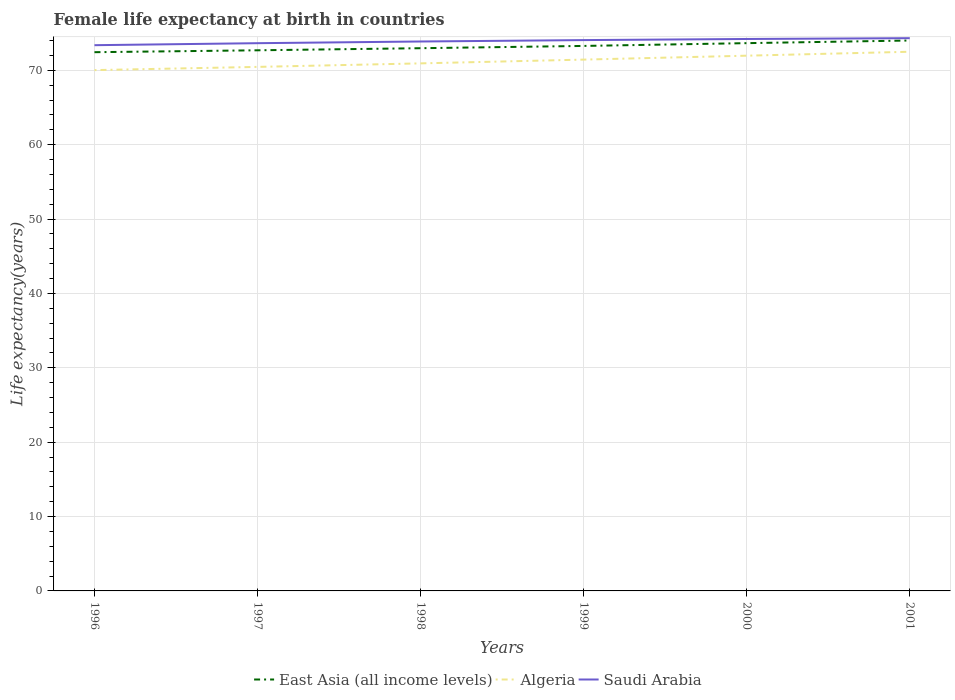How many different coloured lines are there?
Ensure brevity in your answer.  3. Does the line corresponding to Saudi Arabia intersect with the line corresponding to Algeria?
Make the answer very short. No. Across all years, what is the maximum female life expectancy at birth in East Asia (all income levels)?
Offer a very short reply. 72.44. What is the total female life expectancy at birth in Saudi Arabia in the graph?
Your answer should be very brief. -0.11. What is the difference between the highest and the second highest female life expectancy at birth in Saudi Arabia?
Ensure brevity in your answer.  0.94. Is the female life expectancy at birth in East Asia (all income levels) strictly greater than the female life expectancy at birth in Algeria over the years?
Give a very brief answer. No. How many lines are there?
Provide a short and direct response. 3. What is the difference between two consecutive major ticks on the Y-axis?
Make the answer very short. 10. Does the graph contain grids?
Your response must be concise. Yes. Where does the legend appear in the graph?
Ensure brevity in your answer.  Bottom center. How many legend labels are there?
Keep it short and to the point. 3. What is the title of the graph?
Your answer should be very brief. Female life expectancy at birth in countries. Does "Tonga" appear as one of the legend labels in the graph?
Give a very brief answer. No. What is the label or title of the X-axis?
Your answer should be compact. Years. What is the label or title of the Y-axis?
Give a very brief answer. Life expectancy(years). What is the Life expectancy(years) in East Asia (all income levels) in 1996?
Your response must be concise. 72.44. What is the Life expectancy(years) of Algeria in 1996?
Offer a terse response. 70.03. What is the Life expectancy(years) in Saudi Arabia in 1996?
Provide a short and direct response. 73.38. What is the Life expectancy(years) in East Asia (all income levels) in 1997?
Provide a succinct answer. 72.7. What is the Life expectancy(years) in Algeria in 1997?
Your answer should be compact. 70.47. What is the Life expectancy(years) in Saudi Arabia in 1997?
Keep it short and to the point. 73.65. What is the Life expectancy(years) of East Asia (all income levels) in 1998?
Your answer should be compact. 72.98. What is the Life expectancy(years) of Algeria in 1998?
Give a very brief answer. 70.94. What is the Life expectancy(years) in Saudi Arabia in 1998?
Your response must be concise. 73.88. What is the Life expectancy(years) in East Asia (all income levels) in 1999?
Give a very brief answer. 73.28. What is the Life expectancy(years) in Algeria in 1999?
Provide a short and direct response. 71.45. What is the Life expectancy(years) of Saudi Arabia in 1999?
Your answer should be very brief. 74.07. What is the Life expectancy(years) of East Asia (all income levels) in 2000?
Keep it short and to the point. 73.66. What is the Life expectancy(years) in Algeria in 2000?
Provide a short and direct response. 71.97. What is the Life expectancy(years) in Saudi Arabia in 2000?
Offer a very short reply. 74.22. What is the Life expectancy(years) of East Asia (all income levels) in 2001?
Your answer should be compact. 74.01. What is the Life expectancy(years) of Algeria in 2001?
Your response must be concise. 72.5. What is the Life expectancy(years) in Saudi Arabia in 2001?
Keep it short and to the point. 74.33. Across all years, what is the maximum Life expectancy(years) in East Asia (all income levels)?
Give a very brief answer. 74.01. Across all years, what is the maximum Life expectancy(years) in Algeria?
Offer a very short reply. 72.5. Across all years, what is the maximum Life expectancy(years) of Saudi Arabia?
Make the answer very short. 74.33. Across all years, what is the minimum Life expectancy(years) in East Asia (all income levels)?
Offer a terse response. 72.44. Across all years, what is the minimum Life expectancy(years) in Algeria?
Make the answer very short. 70.03. Across all years, what is the minimum Life expectancy(years) in Saudi Arabia?
Your answer should be compact. 73.38. What is the total Life expectancy(years) of East Asia (all income levels) in the graph?
Offer a very short reply. 439.08. What is the total Life expectancy(years) in Algeria in the graph?
Your response must be concise. 427.36. What is the total Life expectancy(years) in Saudi Arabia in the graph?
Your response must be concise. 443.53. What is the difference between the Life expectancy(years) in East Asia (all income levels) in 1996 and that in 1997?
Ensure brevity in your answer.  -0.26. What is the difference between the Life expectancy(years) in Algeria in 1996 and that in 1997?
Ensure brevity in your answer.  -0.43. What is the difference between the Life expectancy(years) of Saudi Arabia in 1996 and that in 1997?
Your answer should be very brief. -0.27. What is the difference between the Life expectancy(years) in East Asia (all income levels) in 1996 and that in 1998?
Keep it short and to the point. -0.54. What is the difference between the Life expectancy(years) of Algeria in 1996 and that in 1998?
Provide a short and direct response. -0.91. What is the difference between the Life expectancy(years) of Saudi Arabia in 1996 and that in 1998?
Your answer should be very brief. -0.5. What is the difference between the Life expectancy(years) of East Asia (all income levels) in 1996 and that in 1999?
Keep it short and to the point. -0.84. What is the difference between the Life expectancy(years) of Algeria in 1996 and that in 1999?
Ensure brevity in your answer.  -1.41. What is the difference between the Life expectancy(years) in Saudi Arabia in 1996 and that in 1999?
Give a very brief answer. -0.69. What is the difference between the Life expectancy(years) of East Asia (all income levels) in 1996 and that in 2000?
Give a very brief answer. -1.22. What is the difference between the Life expectancy(years) in Algeria in 1996 and that in 2000?
Ensure brevity in your answer.  -1.94. What is the difference between the Life expectancy(years) in Saudi Arabia in 1996 and that in 2000?
Make the answer very short. -0.83. What is the difference between the Life expectancy(years) of East Asia (all income levels) in 1996 and that in 2001?
Your answer should be compact. -1.57. What is the difference between the Life expectancy(years) in Algeria in 1996 and that in 2001?
Offer a terse response. -2.47. What is the difference between the Life expectancy(years) of Saudi Arabia in 1996 and that in 2001?
Give a very brief answer. -0.94. What is the difference between the Life expectancy(years) in East Asia (all income levels) in 1997 and that in 1998?
Provide a succinct answer. -0.28. What is the difference between the Life expectancy(years) in Algeria in 1997 and that in 1998?
Ensure brevity in your answer.  -0.47. What is the difference between the Life expectancy(years) in Saudi Arabia in 1997 and that in 1998?
Offer a very short reply. -0.23. What is the difference between the Life expectancy(years) in East Asia (all income levels) in 1997 and that in 1999?
Keep it short and to the point. -0.59. What is the difference between the Life expectancy(years) of Algeria in 1997 and that in 1999?
Keep it short and to the point. -0.98. What is the difference between the Life expectancy(years) in Saudi Arabia in 1997 and that in 1999?
Your answer should be very brief. -0.42. What is the difference between the Life expectancy(years) of East Asia (all income levels) in 1997 and that in 2000?
Keep it short and to the point. -0.96. What is the difference between the Life expectancy(years) in Algeria in 1997 and that in 2000?
Offer a terse response. -1.51. What is the difference between the Life expectancy(years) of Saudi Arabia in 1997 and that in 2000?
Your answer should be compact. -0.56. What is the difference between the Life expectancy(years) of East Asia (all income levels) in 1997 and that in 2001?
Provide a succinct answer. -1.32. What is the difference between the Life expectancy(years) of Algeria in 1997 and that in 2001?
Provide a short and direct response. -2.04. What is the difference between the Life expectancy(years) of Saudi Arabia in 1997 and that in 2001?
Offer a terse response. -0.68. What is the difference between the Life expectancy(years) in East Asia (all income levels) in 1998 and that in 1999?
Ensure brevity in your answer.  -0.3. What is the difference between the Life expectancy(years) of Algeria in 1998 and that in 1999?
Your response must be concise. -0.51. What is the difference between the Life expectancy(years) in Saudi Arabia in 1998 and that in 1999?
Give a very brief answer. -0.19. What is the difference between the Life expectancy(years) of East Asia (all income levels) in 1998 and that in 2000?
Give a very brief answer. -0.68. What is the difference between the Life expectancy(years) of Algeria in 1998 and that in 2000?
Give a very brief answer. -1.03. What is the difference between the Life expectancy(years) in Saudi Arabia in 1998 and that in 2000?
Offer a very short reply. -0.34. What is the difference between the Life expectancy(years) of East Asia (all income levels) in 1998 and that in 2001?
Your answer should be very brief. -1.03. What is the difference between the Life expectancy(years) of Algeria in 1998 and that in 2001?
Keep it short and to the point. -1.56. What is the difference between the Life expectancy(years) of Saudi Arabia in 1998 and that in 2001?
Your answer should be very brief. -0.45. What is the difference between the Life expectancy(years) in East Asia (all income levels) in 1999 and that in 2000?
Provide a succinct answer. -0.37. What is the difference between the Life expectancy(years) of Algeria in 1999 and that in 2000?
Your answer should be very brief. -0.53. What is the difference between the Life expectancy(years) in Saudi Arabia in 1999 and that in 2000?
Keep it short and to the point. -0.15. What is the difference between the Life expectancy(years) in East Asia (all income levels) in 1999 and that in 2001?
Your answer should be compact. -0.73. What is the difference between the Life expectancy(years) of Algeria in 1999 and that in 2001?
Your answer should be compact. -1.06. What is the difference between the Life expectancy(years) in Saudi Arabia in 1999 and that in 2001?
Give a very brief answer. -0.26. What is the difference between the Life expectancy(years) of East Asia (all income levels) in 2000 and that in 2001?
Your answer should be very brief. -0.36. What is the difference between the Life expectancy(years) in Algeria in 2000 and that in 2001?
Make the answer very short. -0.53. What is the difference between the Life expectancy(years) of Saudi Arabia in 2000 and that in 2001?
Your answer should be compact. -0.11. What is the difference between the Life expectancy(years) of East Asia (all income levels) in 1996 and the Life expectancy(years) of Algeria in 1997?
Your answer should be very brief. 1.98. What is the difference between the Life expectancy(years) in East Asia (all income levels) in 1996 and the Life expectancy(years) in Saudi Arabia in 1997?
Give a very brief answer. -1.21. What is the difference between the Life expectancy(years) of Algeria in 1996 and the Life expectancy(years) of Saudi Arabia in 1997?
Your response must be concise. -3.62. What is the difference between the Life expectancy(years) of East Asia (all income levels) in 1996 and the Life expectancy(years) of Algeria in 1998?
Give a very brief answer. 1.5. What is the difference between the Life expectancy(years) in East Asia (all income levels) in 1996 and the Life expectancy(years) in Saudi Arabia in 1998?
Your response must be concise. -1.44. What is the difference between the Life expectancy(years) in Algeria in 1996 and the Life expectancy(years) in Saudi Arabia in 1998?
Give a very brief answer. -3.85. What is the difference between the Life expectancy(years) in East Asia (all income levels) in 1996 and the Life expectancy(years) in Saudi Arabia in 1999?
Offer a terse response. -1.63. What is the difference between the Life expectancy(years) of Algeria in 1996 and the Life expectancy(years) of Saudi Arabia in 1999?
Your answer should be very brief. -4.04. What is the difference between the Life expectancy(years) in East Asia (all income levels) in 1996 and the Life expectancy(years) in Algeria in 2000?
Your answer should be very brief. 0.47. What is the difference between the Life expectancy(years) of East Asia (all income levels) in 1996 and the Life expectancy(years) of Saudi Arabia in 2000?
Your answer should be compact. -1.78. What is the difference between the Life expectancy(years) in Algeria in 1996 and the Life expectancy(years) in Saudi Arabia in 2000?
Give a very brief answer. -4.18. What is the difference between the Life expectancy(years) in East Asia (all income levels) in 1996 and the Life expectancy(years) in Algeria in 2001?
Make the answer very short. -0.06. What is the difference between the Life expectancy(years) of East Asia (all income levels) in 1996 and the Life expectancy(years) of Saudi Arabia in 2001?
Your answer should be very brief. -1.89. What is the difference between the Life expectancy(years) of Algeria in 1996 and the Life expectancy(years) of Saudi Arabia in 2001?
Make the answer very short. -4.29. What is the difference between the Life expectancy(years) in East Asia (all income levels) in 1997 and the Life expectancy(years) in Algeria in 1998?
Provide a short and direct response. 1.76. What is the difference between the Life expectancy(years) in East Asia (all income levels) in 1997 and the Life expectancy(years) in Saudi Arabia in 1998?
Your answer should be very brief. -1.18. What is the difference between the Life expectancy(years) of Algeria in 1997 and the Life expectancy(years) of Saudi Arabia in 1998?
Keep it short and to the point. -3.42. What is the difference between the Life expectancy(years) of East Asia (all income levels) in 1997 and the Life expectancy(years) of Algeria in 1999?
Your answer should be compact. 1.25. What is the difference between the Life expectancy(years) in East Asia (all income levels) in 1997 and the Life expectancy(years) in Saudi Arabia in 1999?
Your answer should be very brief. -1.37. What is the difference between the Life expectancy(years) in Algeria in 1997 and the Life expectancy(years) in Saudi Arabia in 1999?
Offer a very short reply. -3.6. What is the difference between the Life expectancy(years) of East Asia (all income levels) in 1997 and the Life expectancy(years) of Algeria in 2000?
Ensure brevity in your answer.  0.73. What is the difference between the Life expectancy(years) of East Asia (all income levels) in 1997 and the Life expectancy(years) of Saudi Arabia in 2000?
Offer a very short reply. -1.52. What is the difference between the Life expectancy(years) in Algeria in 1997 and the Life expectancy(years) in Saudi Arabia in 2000?
Your answer should be compact. -3.75. What is the difference between the Life expectancy(years) in East Asia (all income levels) in 1997 and the Life expectancy(years) in Algeria in 2001?
Your answer should be very brief. 0.2. What is the difference between the Life expectancy(years) of East Asia (all income levels) in 1997 and the Life expectancy(years) of Saudi Arabia in 2001?
Provide a short and direct response. -1.63. What is the difference between the Life expectancy(years) of Algeria in 1997 and the Life expectancy(years) of Saudi Arabia in 2001?
Give a very brief answer. -3.86. What is the difference between the Life expectancy(years) of East Asia (all income levels) in 1998 and the Life expectancy(years) of Algeria in 1999?
Make the answer very short. 1.53. What is the difference between the Life expectancy(years) of East Asia (all income levels) in 1998 and the Life expectancy(years) of Saudi Arabia in 1999?
Offer a terse response. -1.09. What is the difference between the Life expectancy(years) in Algeria in 1998 and the Life expectancy(years) in Saudi Arabia in 1999?
Offer a terse response. -3.13. What is the difference between the Life expectancy(years) in East Asia (all income levels) in 1998 and the Life expectancy(years) in Saudi Arabia in 2000?
Your answer should be very brief. -1.24. What is the difference between the Life expectancy(years) in Algeria in 1998 and the Life expectancy(years) in Saudi Arabia in 2000?
Your response must be concise. -3.28. What is the difference between the Life expectancy(years) in East Asia (all income levels) in 1998 and the Life expectancy(years) in Algeria in 2001?
Make the answer very short. 0.48. What is the difference between the Life expectancy(years) in East Asia (all income levels) in 1998 and the Life expectancy(years) in Saudi Arabia in 2001?
Your answer should be compact. -1.35. What is the difference between the Life expectancy(years) of Algeria in 1998 and the Life expectancy(years) of Saudi Arabia in 2001?
Your answer should be very brief. -3.39. What is the difference between the Life expectancy(years) in East Asia (all income levels) in 1999 and the Life expectancy(years) in Algeria in 2000?
Ensure brevity in your answer.  1.31. What is the difference between the Life expectancy(years) of East Asia (all income levels) in 1999 and the Life expectancy(years) of Saudi Arabia in 2000?
Provide a succinct answer. -0.93. What is the difference between the Life expectancy(years) in Algeria in 1999 and the Life expectancy(years) in Saudi Arabia in 2000?
Provide a succinct answer. -2.77. What is the difference between the Life expectancy(years) of East Asia (all income levels) in 1999 and the Life expectancy(years) of Algeria in 2001?
Offer a terse response. 0.78. What is the difference between the Life expectancy(years) in East Asia (all income levels) in 1999 and the Life expectancy(years) in Saudi Arabia in 2001?
Your answer should be compact. -1.04. What is the difference between the Life expectancy(years) of Algeria in 1999 and the Life expectancy(years) of Saudi Arabia in 2001?
Ensure brevity in your answer.  -2.88. What is the difference between the Life expectancy(years) of East Asia (all income levels) in 2000 and the Life expectancy(years) of Algeria in 2001?
Offer a very short reply. 1.16. What is the difference between the Life expectancy(years) in East Asia (all income levels) in 2000 and the Life expectancy(years) in Saudi Arabia in 2001?
Ensure brevity in your answer.  -0.67. What is the difference between the Life expectancy(years) in Algeria in 2000 and the Life expectancy(years) in Saudi Arabia in 2001?
Offer a very short reply. -2.35. What is the average Life expectancy(years) of East Asia (all income levels) per year?
Make the answer very short. 73.18. What is the average Life expectancy(years) of Algeria per year?
Ensure brevity in your answer.  71.23. What is the average Life expectancy(years) of Saudi Arabia per year?
Offer a very short reply. 73.92. In the year 1996, what is the difference between the Life expectancy(years) in East Asia (all income levels) and Life expectancy(years) in Algeria?
Provide a succinct answer. 2.41. In the year 1996, what is the difference between the Life expectancy(years) of East Asia (all income levels) and Life expectancy(years) of Saudi Arabia?
Give a very brief answer. -0.94. In the year 1996, what is the difference between the Life expectancy(years) in Algeria and Life expectancy(years) in Saudi Arabia?
Ensure brevity in your answer.  -3.35. In the year 1997, what is the difference between the Life expectancy(years) of East Asia (all income levels) and Life expectancy(years) of Algeria?
Keep it short and to the point. 2.23. In the year 1997, what is the difference between the Life expectancy(years) of East Asia (all income levels) and Life expectancy(years) of Saudi Arabia?
Your response must be concise. -0.95. In the year 1997, what is the difference between the Life expectancy(years) in Algeria and Life expectancy(years) in Saudi Arabia?
Your response must be concise. -3.19. In the year 1998, what is the difference between the Life expectancy(years) of East Asia (all income levels) and Life expectancy(years) of Algeria?
Your answer should be very brief. 2.04. In the year 1998, what is the difference between the Life expectancy(years) in East Asia (all income levels) and Life expectancy(years) in Saudi Arabia?
Provide a short and direct response. -0.9. In the year 1998, what is the difference between the Life expectancy(years) in Algeria and Life expectancy(years) in Saudi Arabia?
Offer a terse response. -2.94. In the year 1999, what is the difference between the Life expectancy(years) in East Asia (all income levels) and Life expectancy(years) in Algeria?
Your answer should be compact. 1.84. In the year 1999, what is the difference between the Life expectancy(years) of East Asia (all income levels) and Life expectancy(years) of Saudi Arabia?
Your response must be concise. -0.78. In the year 1999, what is the difference between the Life expectancy(years) in Algeria and Life expectancy(years) in Saudi Arabia?
Keep it short and to the point. -2.62. In the year 2000, what is the difference between the Life expectancy(years) of East Asia (all income levels) and Life expectancy(years) of Algeria?
Ensure brevity in your answer.  1.69. In the year 2000, what is the difference between the Life expectancy(years) of East Asia (all income levels) and Life expectancy(years) of Saudi Arabia?
Keep it short and to the point. -0.56. In the year 2000, what is the difference between the Life expectancy(years) in Algeria and Life expectancy(years) in Saudi Arabia?
Your response must be concise. -2.25. In the year 2001, what is the difference between the Life expectancy(years) in East Asia (all income levels) and Life expectancy(years) in Algeria?
Keep it short and to the point. 1.51. In the year 2001, what is the difference between the Life expectancy(years) of East Asia (all income levels) and Life expectancy(years) of Saudi Arabia?
Provide a short and direct response. -0.31. In the year 2001, what is the difference between the Life expectancy(years) of Algeria and Life expectancy(years) of Saudi Arabia?
Give a very brief answer. -1.83. What is the ratio of the Life expectancy(years) of East Asia (all income levels) in 1996 to that in 1997?
Offer a terse response. 1. What is the ratio of the Life expectancy(years) in Algeria in 1996 to that in 1997?
Provide a succinct answer. 0.99. What is the ratio of the Life expectancy(years) of Saudi Arabia in 1996 to that in 1997?
Offer a very short reply. 1. What is the ratio of the Life expectancy(years) of East Asia (all income levels) in 1996 to that in 1998?
Offer a very short reply. 0.99. What is the ratio of the Life expectancy(years) of Algeria in 1996 to that in 1998?
Offer a very short reply. 0.99. What is the ratio of the Life expectancy(years) of Saudi Arabia in 1996 to that in 1998?
Provide a succinct answer. 0.99. What is the ratio of the Life expectancy(years) in East Asia (all income levels) in 1996 to that in 1999?
Your answer should be very brief. 0.99. What is the ratio of the Life expectancy(years) of Algeria in 1996 to that in 1999?
Offer a very short reply. 0.98. What is the ratio of the Life expectancy(years) in Saudi Arabia in 1996 to that in 1999?
Give a very brief answer. 0.99. What is the ratio of the Life expectancy(years) in East Asia (all income levels) in 1996 to that in 2000?
Give a very brief answer. 0.98. What is the ratio of the Life expectancy(years) in Algeria in 1996 to that in 2000?
Provide a short and direct response. 0.97. What is the ratio of the Life expectancy(years) of Saudi Arabia in 1996 to that in 2000?
Provide a succinct answer. 0.99. What is the ratio of the Life expectancy(years) of East Asia (all income levels) in 1996 to that in 2001?
Ensure brevity in your answer.  0.98. What is the ratio of the Life expectancy(years) of Algeria in 1996 to that in 2001?
Offer a terse response. 0.97. What is the ratio of the Life expectancy(years) of Saudi Arabia in 1996 to that in 2001?
Your answer should be very brief. 0.99. What is the ratio of the Life expectancy(years) in Algeria in 1997 to that in 1998?
Offer a very short reply. 0.99. What is the ratio of the Life expectancy(years) of Saudi Arabia in 1997 to that in 1998?
Keep it short and to the point. 1. What is the ratio of the Life expectancy(years) of East Asia (all income levels) in 1997 to that in 1999?
Your answer should be compact. 0.99. What is the ratio of the Life expectancy(years) of Algeria in 1997 to that in 1999?
Offer a terse response. 0.99. What is the ratio of the Life expectancy(years) of Saudi Arabia in 1997 to that in 1999?
Ensure brevity in your answer.  0.99. What is the ratio of the Life expectancy(years) of Algeria in 1997 to that in 2000?
Provide a succinct answer. 0.98. What is the ratio of the Life expectancy(years) of East Asia (all income levels) in 1997 to that in 2001?
Give a very brief answer. 0.98. What is the ratio of the Life expectancy(years) in Algeria in 1997 to that in 2001?
Your answer should be very brief. 0.97. What is the ratio of the Life expectancy(years) of Saudi Arabia in 1997 to that in 2001?
Offer a terse response. 0.99. What is the ratio of the Life expectancy(years) of East Asia (all income levels) in 1998 to that in 1999?
Keep it short and to the point. 1. What is the ratio of the Life expectancy(years) of East Asia (all income levels) in 1998 to that in 2000?
Make the answer very short. 0.99. What is the ratio of the Life expectancy(years) in Algeria in 1998 to that in 2000?
Your response must be concise. 0.99. What is the ratio of the Life expectancy(years) of East Asia (all income levels) in 1998 to that in 2001?
Your answer should be very brief. 0.99. What is the ratio of the Life expectancy(years) of Algeria in 1998 to that in 2001?
Your response must be concise. 0.98. What is the ratio of the Life expectancy(years) of Saudi Arabia in 1998 to that in 2001?
Ensure brevity in your answer.  0.99. What is the ratio of the Life expectancy(years) of Saudi Arabia in 1999 to that in 2000?
Make the answer very short. 1. What is the ratio of the Life expectancy(years) in Algeria in 1999 to that in 2001?
Give a very brief answer. 0.99. What is the ratio of the Life expectancy(years) in Saudi Arabia in 1999 to that in 2001?
Make the answer very short. 1. What is the ratio of the Life expectancy(years) of East Asia (all income levels) in 2000 to that in 2001?
Ensure brevity in your answer.  1. What is the ratio of the Life expectancy(years) in Algeria in 2000 to that in 2001?
Provide a short and direct response. 0.99. What is the ratio of the Life expectancy(years) of Saudi Arabia in 2000 to that in 2001?
Give a very brief answer. 1. What is the difference between the highest and the second highest Life expectancy(years) of East Asia (all income levels)?
Your answer should be very brief. 0.36. What is the difference between the highest and the second highest Life expectancy(years) of Algeria?
Your response must be concise. 0.53. What is the difference between the highest and the second highest Life expectancy(years) of Saudi Arabia?
Ensure brevity in your answer.  0.11. What is the difference between the highest and the lowest Life expectancy(years) of East Asia (all income levels)?
Offer a terse response. 1.57. What is the difference between the highest and the lowest Life expectancy(years) of Algeria?
Keep it short and to the point. 2.47. What is the difference between the highest and the lowest Life expectancy(years) of Saudi Arabia?
Your answer should be compact. 0.94. 